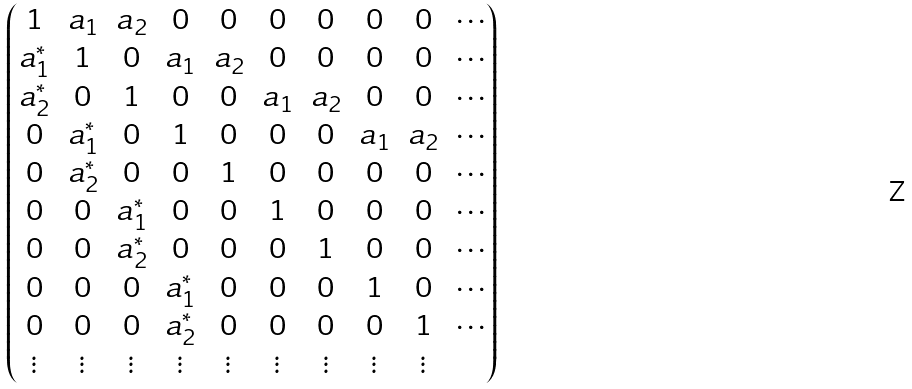<formula> <loc_0><loc_0><loc_500><loc_500>\begin{pmatrix} 1 & a _ { 1 } & a _ { 2 } & 0 & 0 & 0 & 0 & 0 & 0 & \cdots \\ a ^ { * } _ { 1 } & 1 & 0 & a _ { 1 } & a _ { 2 } & 0 & 0 & 0 & 0 & \cdots \\ a ^ { * } _ { 2 } & 0 & 1 & 0 & 0 & a _ { 1 } & a _ { 2 } & 0 & 0 & \cdots \\ 0 & a _ { 1 } ^ { * } & 0 & 1 & 0 & 0 & 0 & a _ { 1 } & a _ { 2 } & \cdots \\ 0 & a _ { 2 } ^ { * } & 0 & 0 & 1 & 0 & 0 & 0 & 0 & \cdots \\ 0 & 0 & a _ { 1 } ^ { * } & 0 & 0 & 1 & 0 & 0 & 0 & \cdots \\ 0 & 0 & a _ { 2 } ^ { * } & 0 & 0 & 0 & 1 & 0 & 0 & \cdots \\ 0 & 0 & 0 & a _ { 1 } ^ { * } & 0 & 0 & 0 & 1 & 0 & \cdots \\ 0 & 0 & 0 & a _ { 2 } ^ { * } & 0 & 0 & 0 & 0 & 1 & \cdots \\ \vdots & \vdots & \vdots & \vdots & \vdots & \vdots & \vdots & \vdots & \vdots & \\ \end{pmatrix}</formula> 